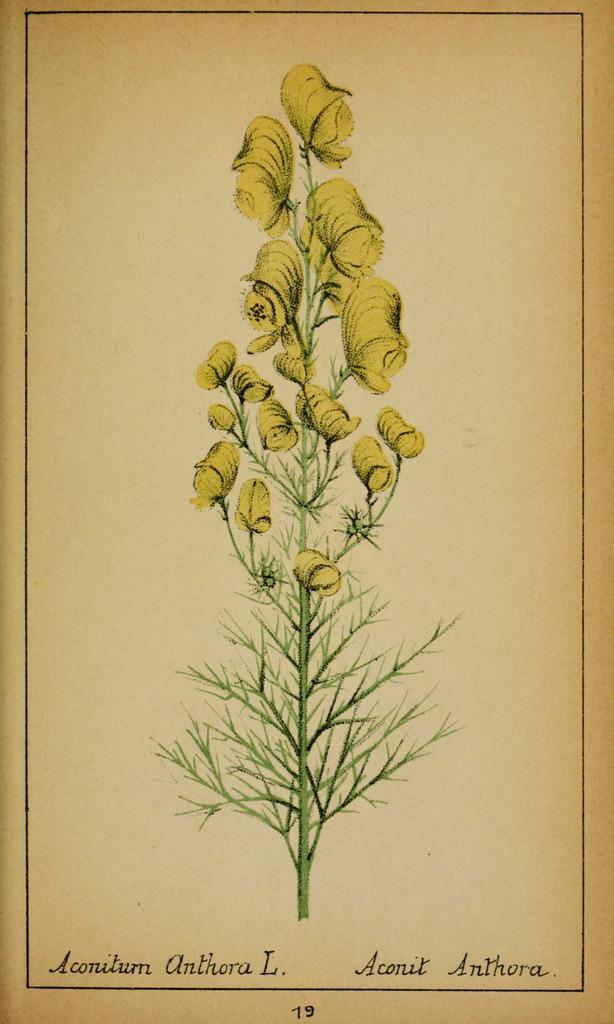Describe this image in one or two sentences. This image consists of a paper with an image of a plant with stems, leaves and a few flowers and there is a text on it. 